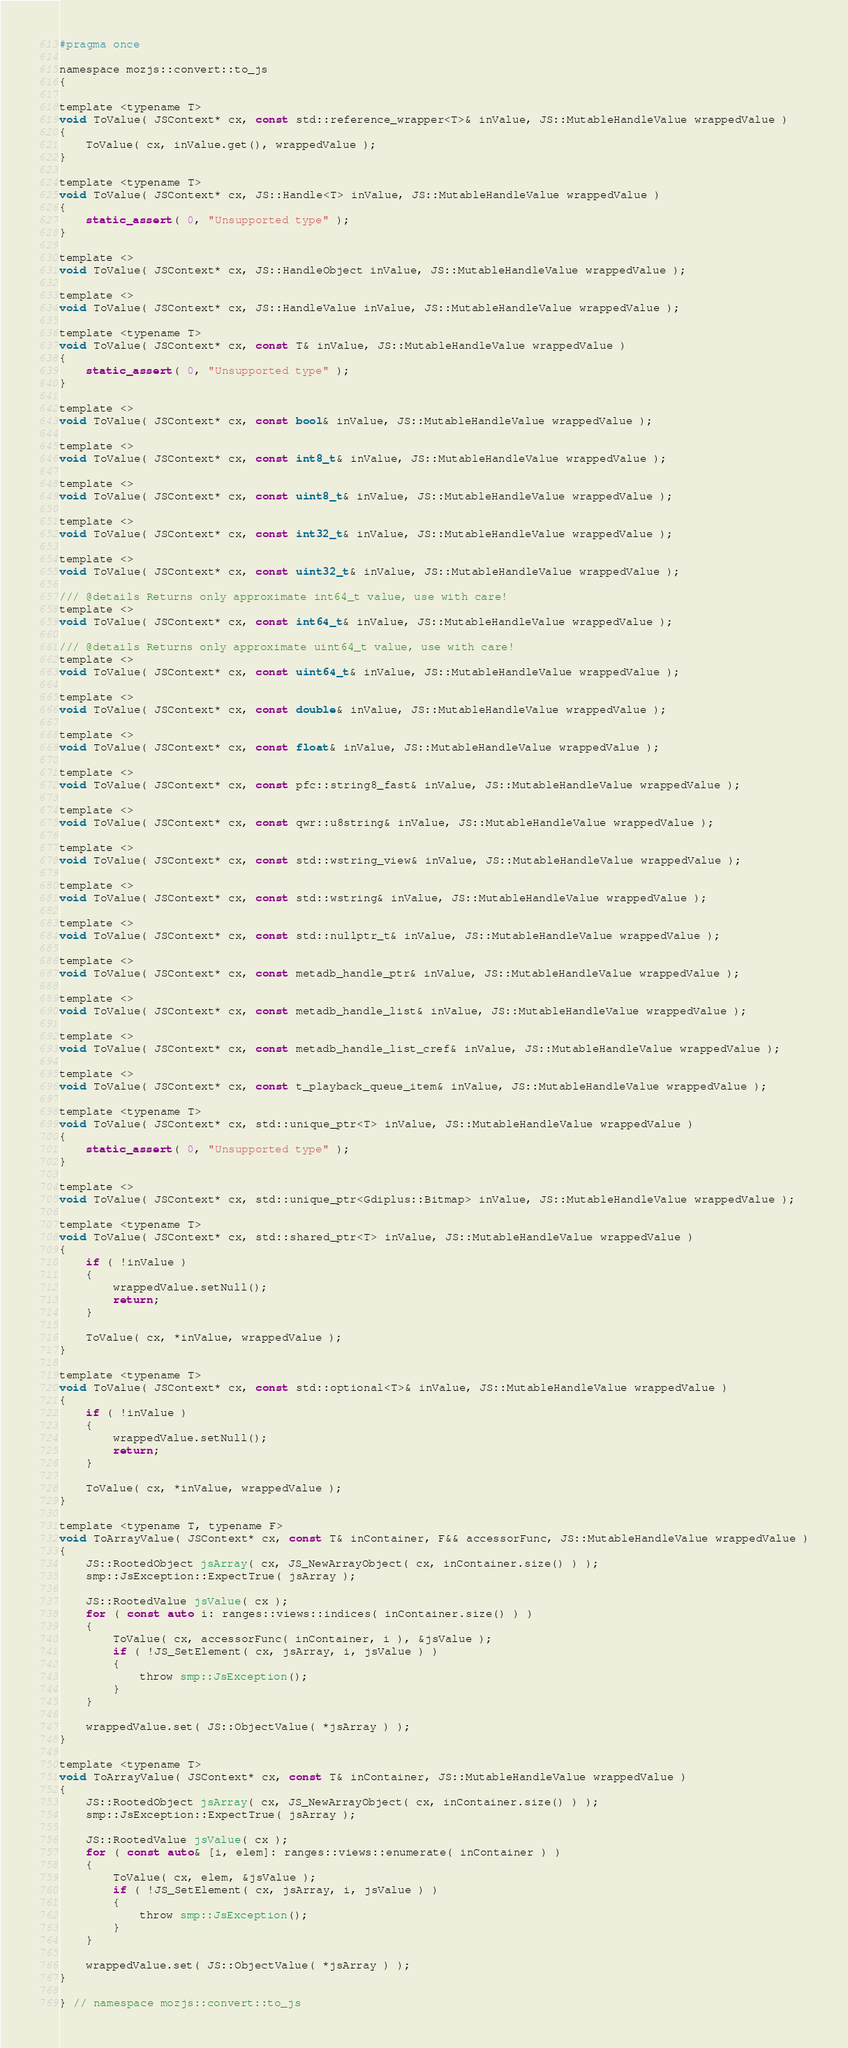Convert code to text. <code><loc_0><loc_0><loc_500><loc_500><_C_>#pragma once

namespace mozjs::convert::to_js
{

template <typename T>
void ToValue( JSContext* cx, const std::reference_wrapper<T>& inValue, JS::MutableHandleValue wrappedValue )
{
    ToValue( cx, inValue.get(), wrappedValue );
}

template <typename T>
void ToValue( JSContext* cx, JS::Handle<T> inValue, JS::MutableHandleValue wrappedValue )
{
    static_assert( 0, "Unsupported type" );
}

template <>
void ToValue( JSContext* cx, JS::HandleObject inValue, JS::MutableHandleValue wrappedValue );

template <>
void ToValue( JSContext* cx, JS::HandleValue inValue, JS::MutableHandleValue wrappedValue );

template <typename T>
void ToValue( JSContext* cx, const T& inValue, JS::MutableHandleValue wrappedValue )
{
    static_assert( 0, "Unsupported type" );
}

template <>
void ToValue( JSContext* cx, const bool& inValue, JS::MutableHandleValue wrappedValue );

template <>
void ToValue( JSContext* cx, const int8_t& inValue, JS::MutableHandleValue wrappedValue );

template <>
void ToValue( JSContext* cx, const uint8_t& inValue, JS::MutableHandleValue wrappedValue );

template <>
void ToValue( JSContext* cx, const int32_t& inValue, JS::MutableHandleValue wrappedValue );

template <>
void ToValue( JSContext* cx, const uint32_t& inValue, JS::MutableHandleValue wrappedValue );

/// @details Returns only approximate int64_t value, use with care!
template <>
void ToValue( JSContext* cx, const int64_t& inValue, JS::MutableHandleValue wrappedValue );

/// @details Returns only approximate uint64_t value, use with care!
template <>
void ToValue( JSContext* cx, const uint64_t& inValue, JS::MutableHandleValue wrappedValue );

template <>
void ToValue( JSContext* cx, const double& inValue, JS::MutableHandleValue wrappedValue );

template <>
void ToValue( JSContext* cx, const float& inValue, JS::MutableHandleValue wrappedValue );

template <>
void ToValue( JSContext* cx, const pfc::string8_fast& inValue, JS::MutableHandleValue wrappedValue );

template <>
void ToValue( JSContext* cx, const qwr::u8string& inValue, JS::MutableHandleValue wrappedValue );

template <>
void ToValue( JSContext* cx, const std::wstring_view& inValue, JS::MutableHandleValue wrappedValue );

template <>
void ToValue( JSContext* cx, const std::wstring& inValue, JS::MutableHandleValue wrappedValue );

template <>
void ToValue( JSContext* cx, const std::nullptr_t& inValue, JS::MutableHandleValue wrappedValue );

template <>
void ToValue( JSContext* cx, const metadb_handle_ptr& inValue, JS::MutableHandleValue wrappedValue );

template <>
void ToValue( JSContext* cx, const metadb_handle_list& inValue, JS::MutableHandleValue wrappedValue );

template <>
void ToValue( JSContext* cx, const metadb_handle_list_cref& inValue, JS::MutableHandleValue wrappedValue );

template <>
void ToValue( JSContext* cx, const t_playback_queue_item& inValue, JS::MutableHandleValue wrappedValue );

template <typename T>
void ToValue( JSContext* cx, std::unique_ptr<T> inValue, JS::MutableHandleValue wrappedValue )
{
    static_assert( 0, "Unsupported type" );
}

template <>
void ToValue( JSContext* cx, std::unique_ptr<Gdiplus::Bitmap> inValue, JS::MutableHandleValue wrappedValue );

template <typename T>
void ToValue( JSContext* cx, std::shared_ptr<T> inValue, JS::MutableHandleValue wrappedValue )
{
    if ( !inValue )
    {
        wrappedValue.setNull();
        return;
    }

    ToValue( cx, *inValue, wrappedValue );
}

template <typename T>
void ToValue( JSContext* cx, const std::optional<T>& inValue, JS::MutableHandleValue wrappedValue )
{
    if ( !inValue )
    {
        wrappedValue.setNull();
        return;
    }

    ToValue( cx, *inValue, wrappedValue );
}

template <typename T, typename F>
void ToArrayValue( JSContext* cx, const T& inContainer, F&& accessorFunc, JS::MutableHandleValue wrappedValue )
{
    JS::RootedObject jsArray( cx, JS_NewArrayObject( cx, inContainer.size() ) );
    smp::JsException::ExpectTrue( jsArray );

    JS::RootedValue jsValue( cx );
    for ( const auto i: ranges::views::indices( inContainer.size() ) )
    {
        ToValue( cx, accessorFunc( inContainer, i ), &jsValue );
        if ( !JS_SetElement( cx, jsArray, i, jsValue ) )
        {
            throw smp::JsException();
        }
    }

    wrappedValue.set( JS::ObjectValue( *jsArray ) );
}

template <typename T>
void ToArrayValue( JSContext* cx, const T& inContainer, JS::MutableHandleValue wrappedValue )
{
    JS::RootedObject jsArray( cx, JS_NewArrayObject( cx, inContainer.size() ) );
    smp::JsException::ExpectTrue( jsArray );

    JS::RootedValue jsValue( cx );
    for ( const auto& [i, elem]: ranges::views::enumerate( inContainer ) )
    {
        ToValue( cx, elem, &jsValue );
        if ( !JS_SetElement( cx, jsArray, i, jsValue ) )
        {
            throw smp::JsException();
        }
    }

    wrappedValue.set( JS::ObjectValue( *jsArray ) );
}

} // namespace mozjs::convert::to_js
</code> 